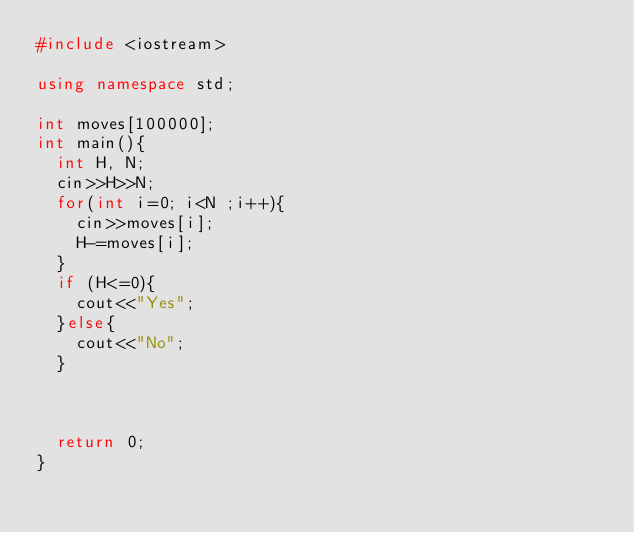<code> <loc_0><loc_0><loc_500><loc_500><_C++_>#include <iostream>

using namespace std;

int moves[100000];
int main(){
  int H, N;
  cin>>H>>N;
  for(int i=0; i<N ;i++){
    cin>>moves[i];
    H-=moves[i];
  }
  if (H<=0){
    cout<<"Yes";
  }else{
    cout<<"No";
  }



  return 0;
}</code> 